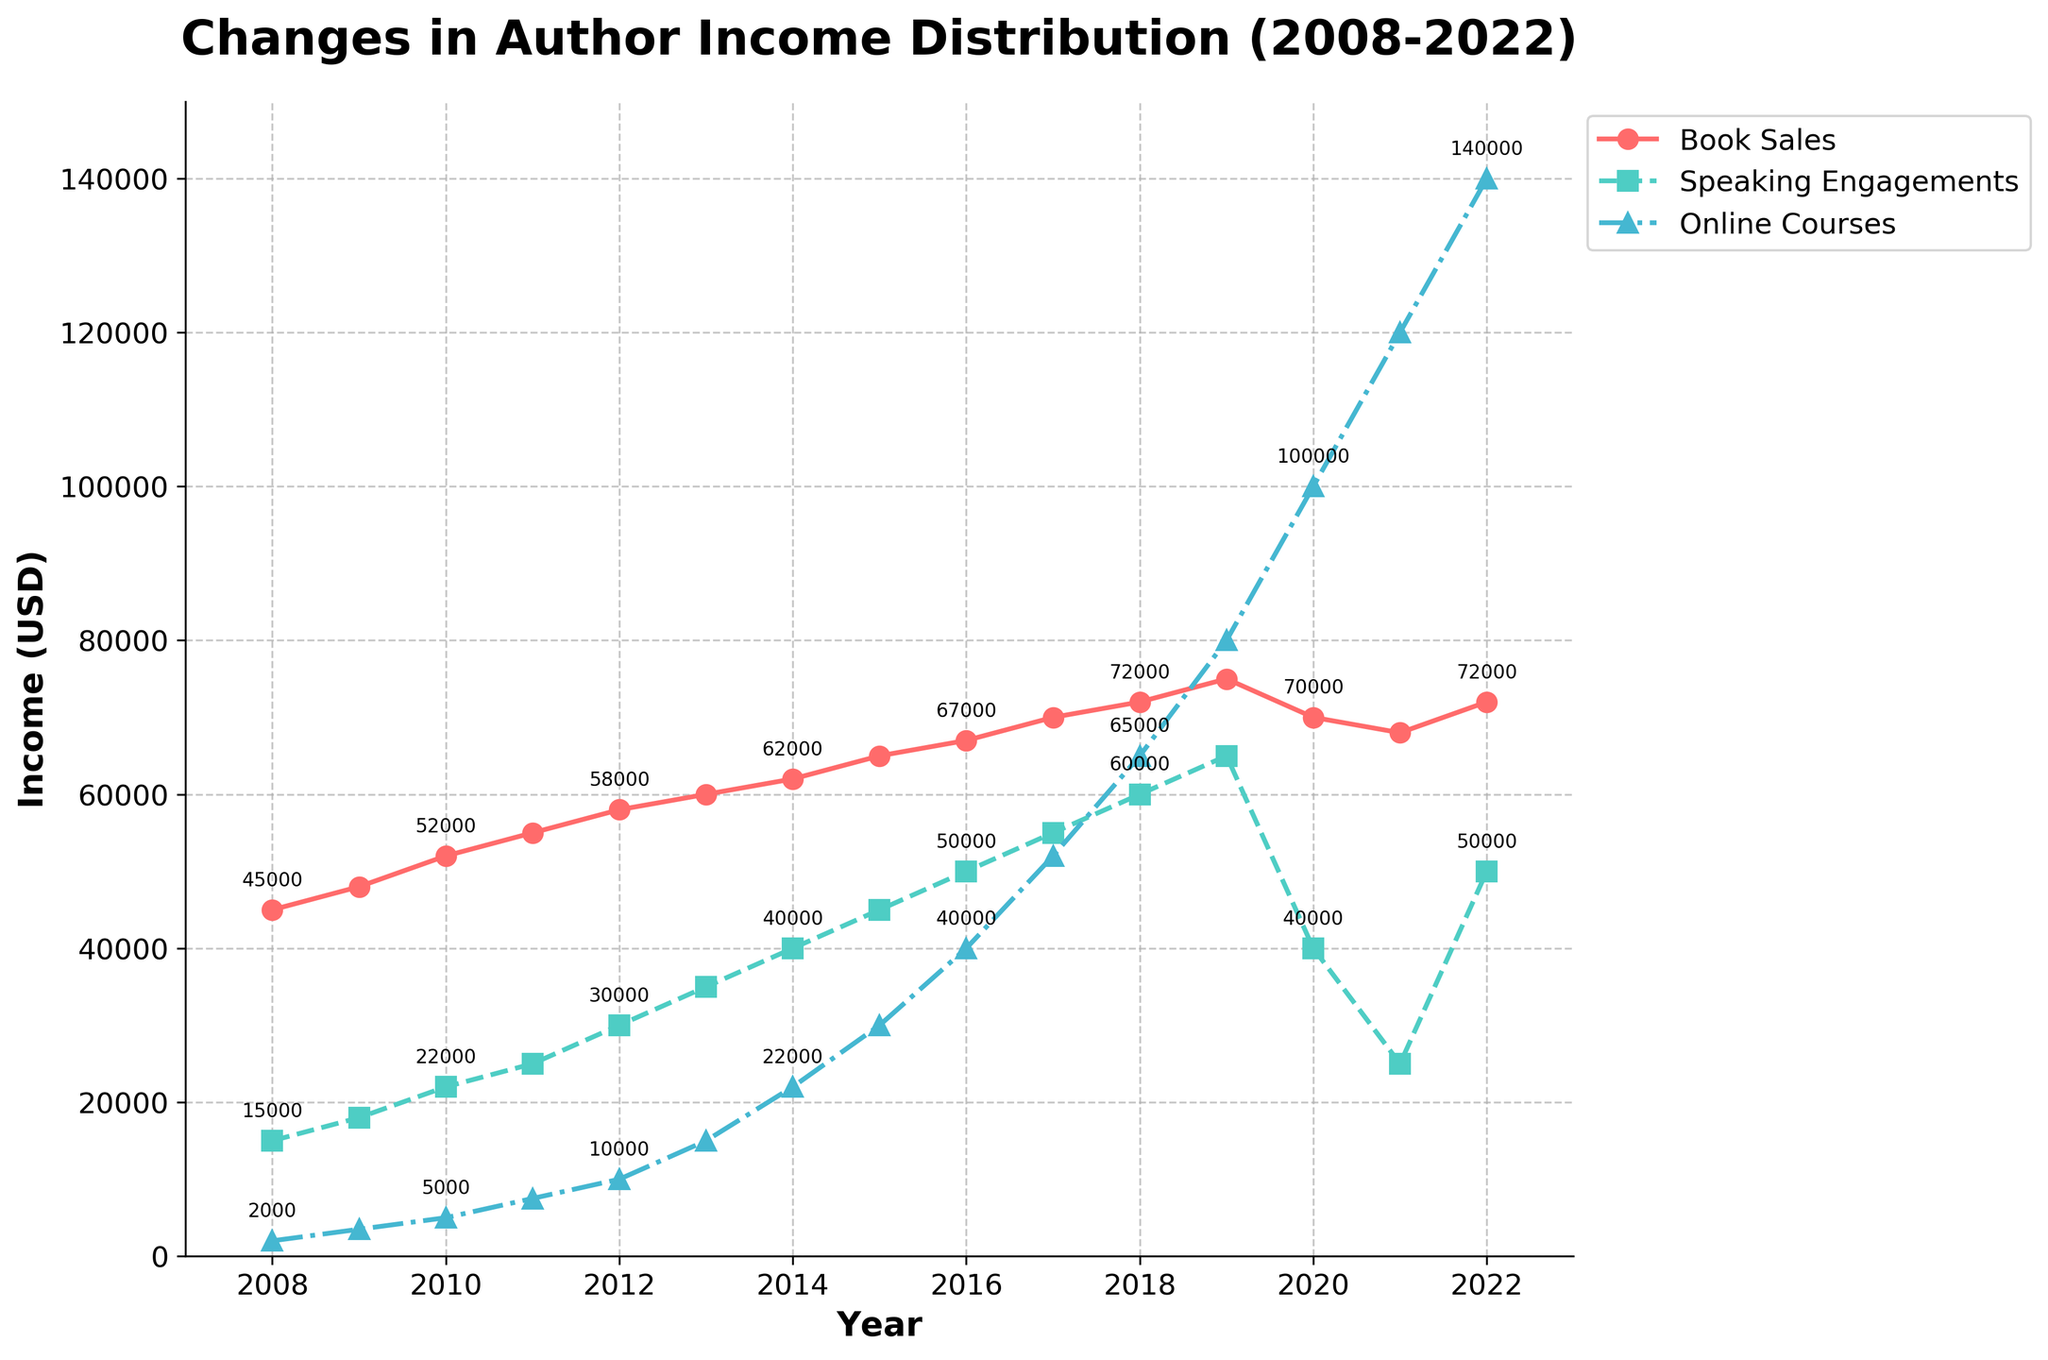What is the total income from Book Sales in 2012? To find the total income from Book Sales in 2012, refer to the value indicated by the red line (circle markers) for the year 2012. The value is $58,000.
Answer: $58,000 Which year saw the highest income from Online Courses, and what was that amount? To find the year with the highest income from Online Courses, locate the highest peak of the blue line (triangle markers). The peak around the highest point occurs in 2022 with a value of $140,000.
Answer: 2022, $140,000 How does the income from Speaking Engagements in 2020 compare to that in 2021? Compare the values of the green line (square markers) for the years 2020 and 2021. In 2020, the income was $40,000, and in 2021, the income was $25,000, showing a decrease.
Answer: $40,000 in 2020, $25,000 in 2021 What is the difference in income from Book Sales between 2008 and 2018? Subtract the income from Book Sales in 2008 from the income in 2018. The value in 2008 is $45,000 and in 2018 is $72,000, so the difference is $72,000 - $45,000 = $27,000.
Answer: $27,000 Which revenue stream experienced the most significant increase from 2008 to 2022? Calculate the increase for each revenue stream: 
- Book Sales: $72,000 (2022) - $45,000 (2008) = $27,000
- Speaking Engagements: $50,000 (2022) - $15,000 (2008) = $35,000
- Online Courses: $140,000 (2022) - $2,000 (2008) = $138,000
Online Courses had the most significant increase.
Answer: Online Courses What was the average income from Speaking Engagements between 2010 and 2015? Add the incomes for each year from 2010 to 2015 and divide by the number of years.
Income values: $22,000 (2010), $25,000 (2011), $30,000 (2012), $35,000 (2013), $40,000 (2014), $45,000 (2015).
Sum = $22,000 + $25,000 + $30,000 + $35,000 + $40,000 + $45,000 = $197,000.
Average = $197,000 / 6 = $32,833.
Answer: $32,833 In which year did the income from Online Courses surpass the income from Book Sales for the first time? Compare the lines (triangle markers for Online Courses and circle markers for Book Sales). Online Courses first surpassed Book Sales in 2019.
Answer: 2019 